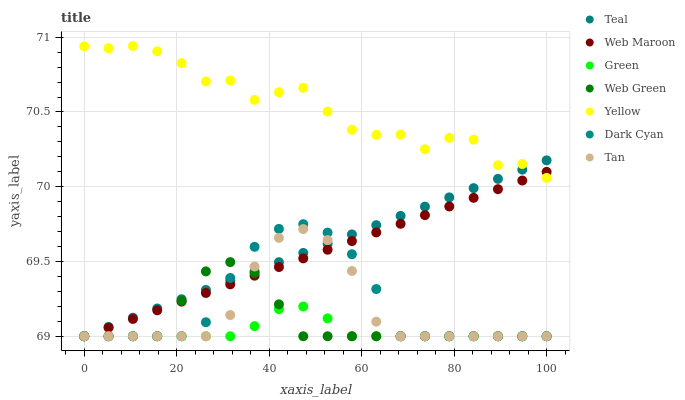Does Green have the minimum area under the curve?
Answer yes or no. Yes. Does Yellow have the maximum area under the curve?
Answer yes or no. Yes. Does Yellow have the minimum area under the curve?
Answer yes or no. No. Does Green have the maximum area under the curve?
Answer yes or no. No. Is Web Maroon the smoothest?
Answer yes or no. Yes. Is Yellow the roughest?
Answer yes or no. Yes. Is Green the smoothest?
Answer yes or no. No. Is Green the roughest?
Answer yes or no. No. Does Web Maroon have the lowest value?
Answer yes or no. Yes. Does Yellow have the lowest value?
Answer yes or no. No. Does Yellow have the highest value?
Answer yes or no. Yes. Does Green have the highest value?
Answer yes or no. No. Is Green less than Yellow?
Answer yes or no. Yes. Is Yellow greater than Green?
Answer yes or no. Yes. Does Web Green intersect Dark Cyan?
Answer yes or no. Yes. Is Web Green less than Dark Cyan?
Answer yes or no. No. Is Web Green greater than Dark Cyan?
Answer yes or no. No. Does Green intersect Yellow?
Answer yes or no. No. 